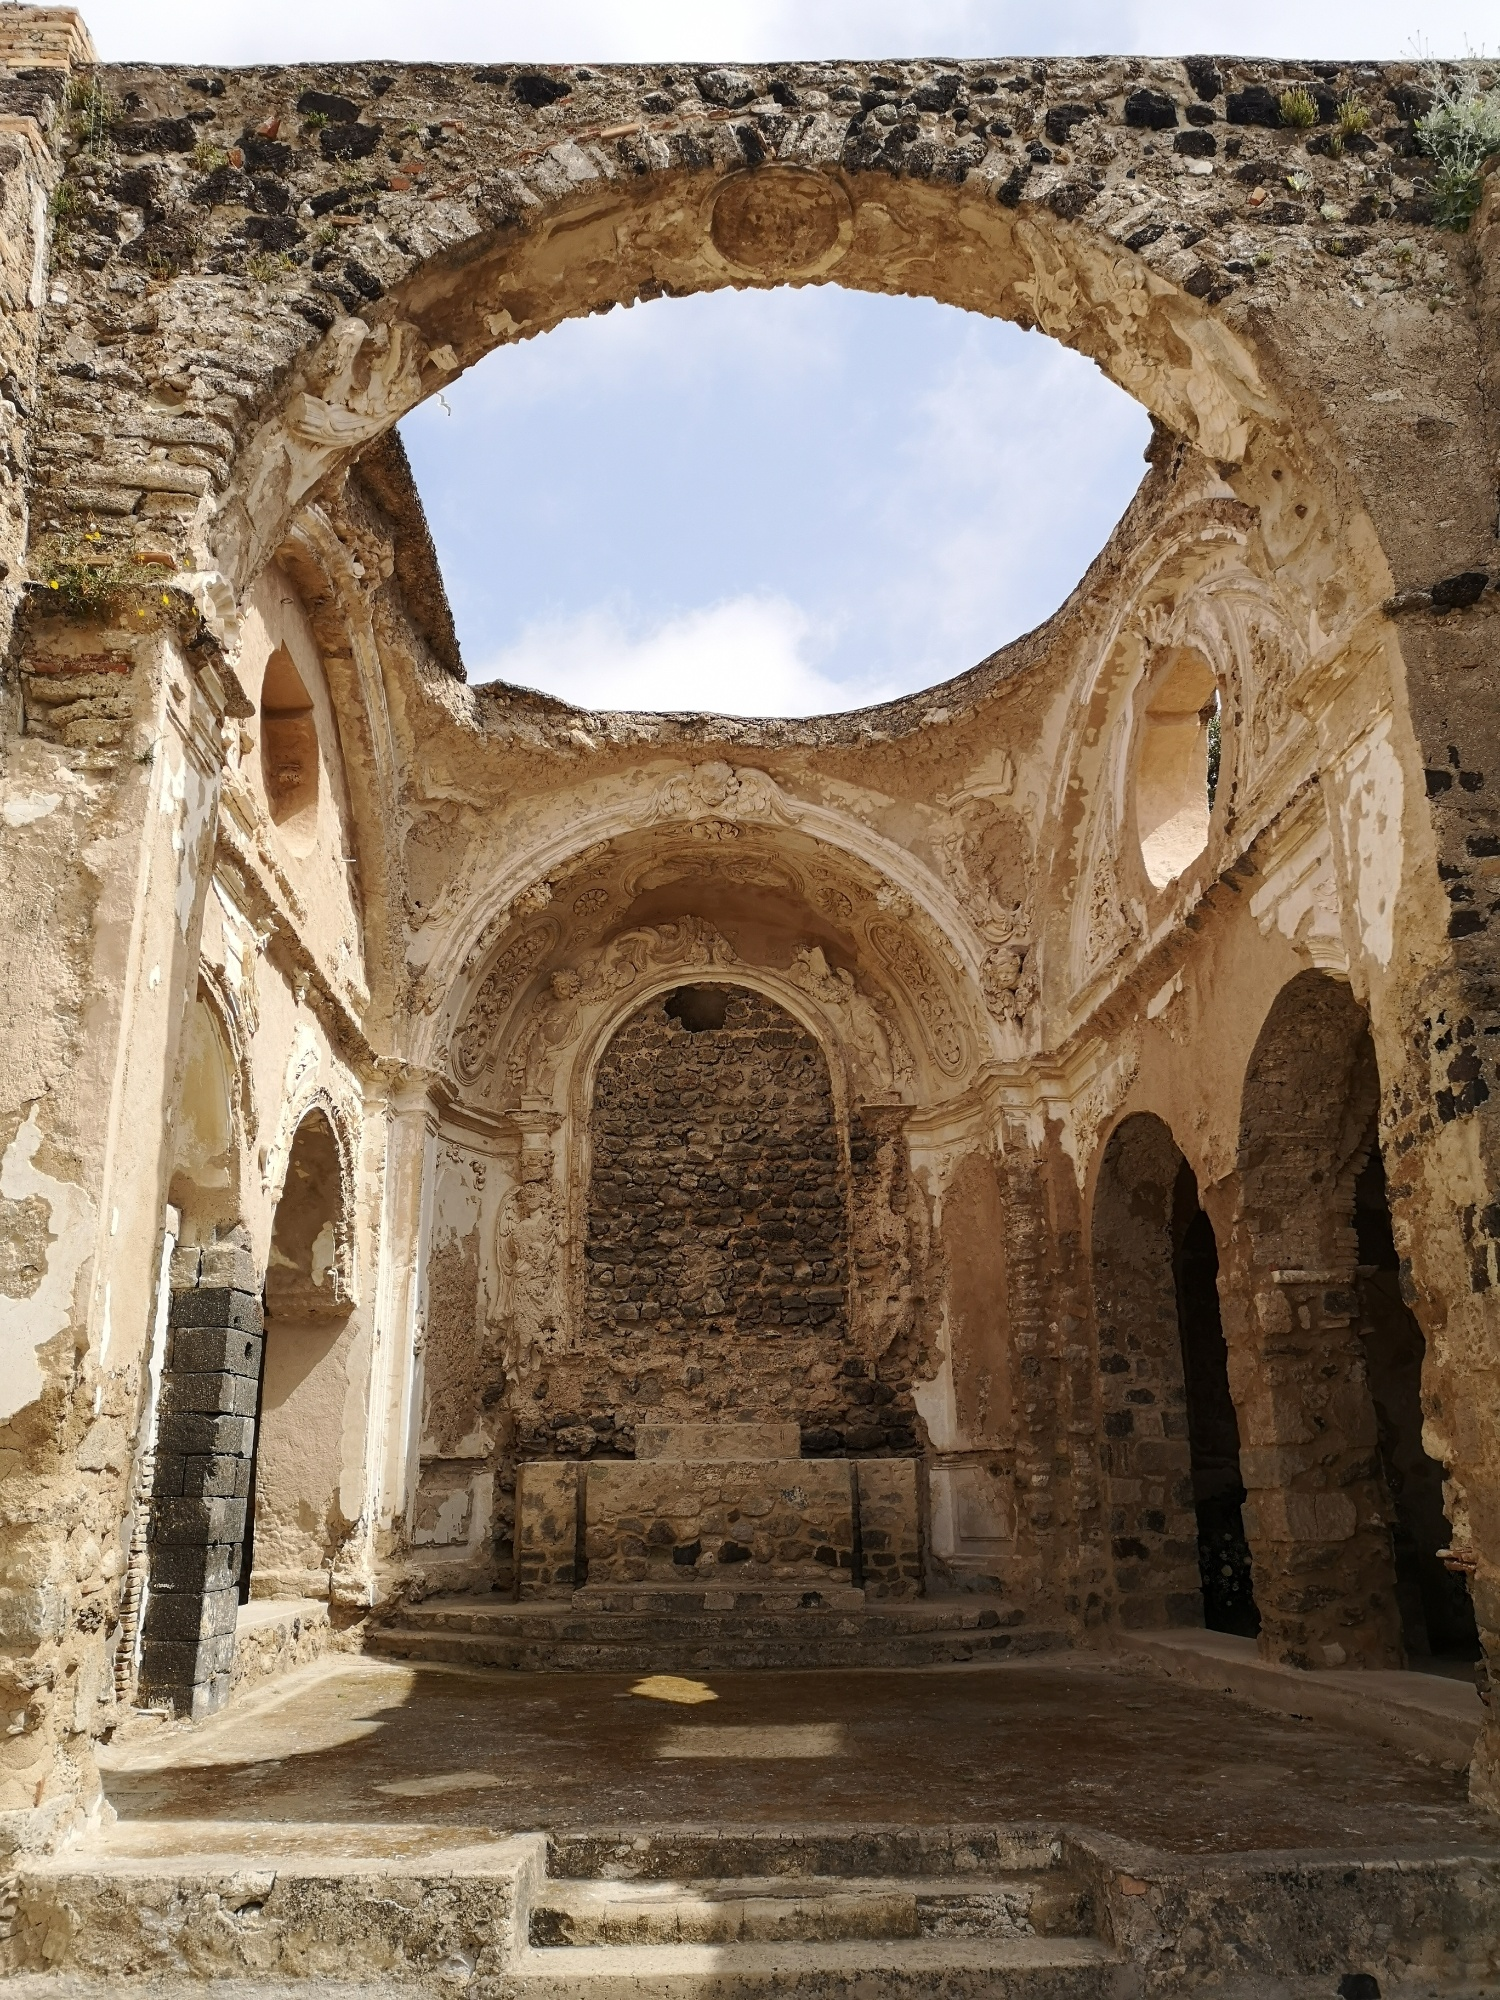If this structure could speak, what stories do you think it would tell? If this ancient structure could speak, it would narrate countless tales of faith, power, and human endurance. It would recount days of vibrant gatherings where the faithful came to seek solace, celebrate, and mourn. It would speak of the master craftsmen who toiled day and night to carve the delicate patterns adorning its walls, infusing their artistry with devotion. The structure would tell stories of grand ceremonies, rich with tradition, and moments of tranquility where individuals found peace within its sacred confines. It would remember the tumultuous times of invasions and conflicts when it stood resilient against the ravages of war. Through whispers of its fading stone, it would share the wisdom of the ages, encapsulating centuries of human history and the undying spirit of community and faith that it once fostered. What kind of events or rituals might have taken place here? The structure likely hosted a variety of significant religious and community events. Grand masses and church services, complete with choir singing and organ music, would have filled the space with divine ambience. Baptisms and weddings, pivotal in the lives of community members, were probably celebrated here with familial gatherings and religious fervor. During important religious festivals, this place would have been adorned with candles, flowers, and vibrant decorations, drawing people from near and far. Processions and pilgrimages might have converged at this spot, marking it as a notable spiritual destination. Additionally, the structure could have served as a haven during times of crisis, providing shelter and solace to the needy and the afflicted. 